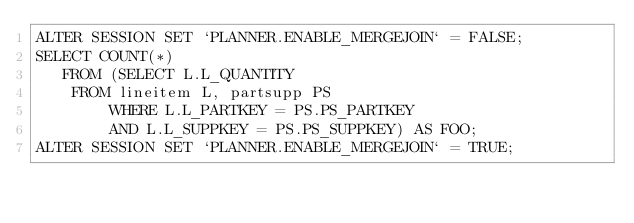<code> <loc_0><loc_0><loc_500><loc_500><_SQL_>ALTER SESSION SET `PLANNER.ENABLE_MERGEJOIN` = FALSE;
SELECT COUNT(*) 
   FROM (SELECT L.L_QUANTITY 
	FROM lineitem L, partsupp PS 
		WHERE L.L_PARTKEY = PS.PS_PARTKEY 
        AND L.L_SUPPKEY = PS.PS_SUPPKEY) AS FOO;
ALTER SESSION SET `PLANNER.ENABLE_MERGEJOIN` = TRUE;
</code> 